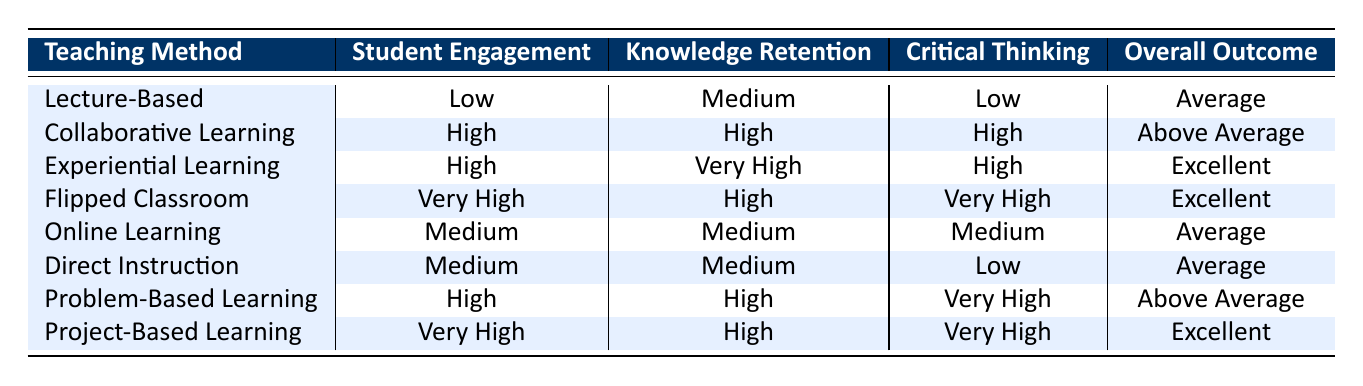What is the overall outcome of Collaborative Learning? The table indicates that the overall outcome for Collaborative Learning is listed as "Above Average." This can be directly found in the row corresponding to the Collaborative Learning method.
Answer: Above Average Which teaching method has the highest student engagement? The method with the highest student engagement is Flipped Classroom, which is marked as "Very High." This is evident from comparing the student engagement levels across all teaching methods.
Answer: Flipped Classroom Is the knowledge retention for Lecture-Based teaching method high? No, the knowledge retention for the Lecture-Based method is rated as "Medium," which is stated clearly in the corresponding row.
Answer: No What are the overall outcomes for teaching methods with high critical thinking? The methods that have high critical thinking (listed as "High") are Collaborative Learning and Problem-Based Learning, which have the overall outcomes of "Above Average." Therefore, their outcomes indicate a positive impact when critical thinking is emphasized.
Answer: Above Average How many teaching methods have an overall outcome of Excellent? There are three methods with an overall outcome of Excellent: Experiential Learning, Flipped Classroom, and Project-Based Learning. The overall outcomes listed in the table allow for easy counting of methods rated as Excellent.
Answer: 3 Which teaching method has a combination of high student engagement and very high critical thinking? The Flipped Classroom method meets both criteria; it has "Very High" student engagement and "Very High" critical thinking according to the data in the table.
Answer: Flipped Classroom Are there any teaching methods where student engagement is classified as Low? Yes, there is one teaching method, Lecture-Based, with student engagement classified as "Low," which is directly pullable from the corresponding row in the table.
Answer: Yes What is the average knowledge retention level of methods with an overall outcome of Excellent? The knowledge retention levels for the methods with an Excellent outcome are Very High for Experiential Learning, and High for both Flipped Classroom and Project-Based Learning. To find the average, we convert these labels: Very High (4) and High (3) to numeric values. Average = (4 + 3 + 3) / 3 = 10 / 3 = 3.33, which corresponds to a level slightly above High.
Answer: Above High 